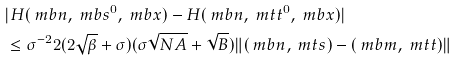Convert formula to latex. <formula><loc_0><loc_0><loc_500><loc_500>& | H ( \ m b n , \ m b s ^ { 0 } , \ m b x ) - H ( \ m b n , \ m t t ^ { 0 } , \ m b x ) | \\ & \leq \sigma ^ { - 2 } 2 ( 2 \sqrt { \beta } + \sigma ) ( \sigma \sqrt { N A } + \sqrt { B } ) \| ( \ m b n , \ m t s ) - ( \ m b m , \ m t t ) \|</formula> 